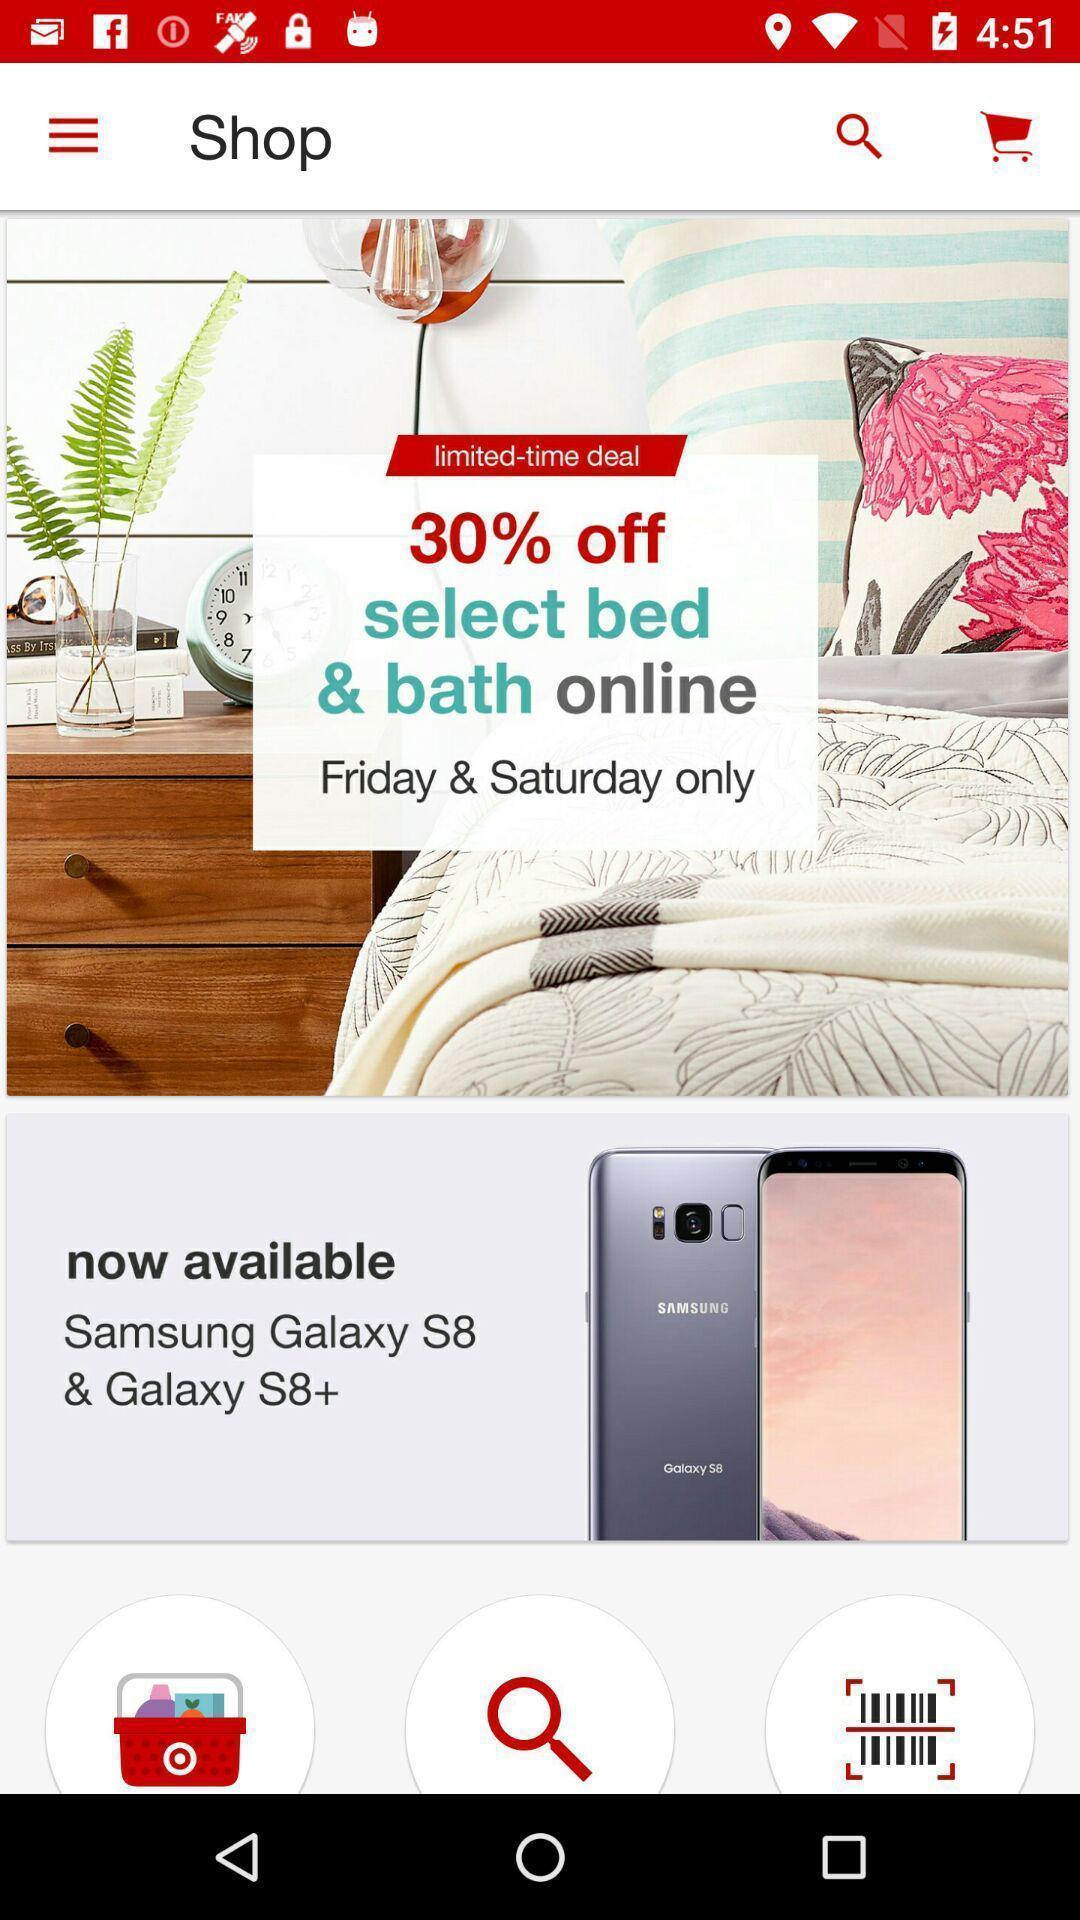Explain what's happening in this screen capture. Pop up of the offer select. 